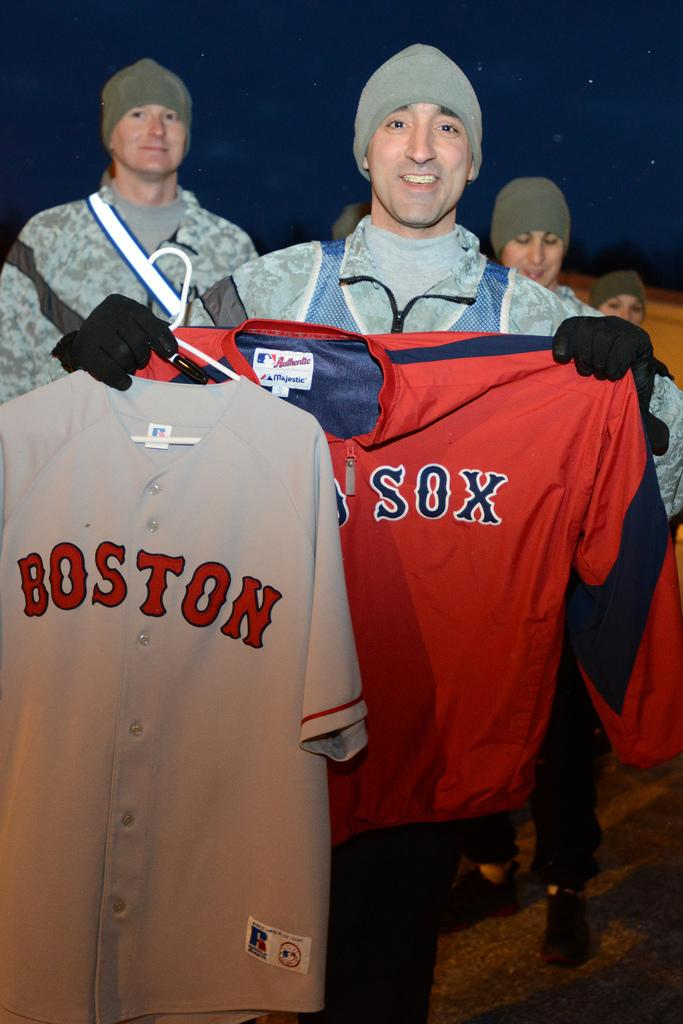What are the people in the image doing? The people in the image are standing and holding t-shirts in their hands. What else can be observed about the people in the image? The people are wearing caps. What type of sidewalk can be seen in the image? There is no sidewalk present in the image. Who is the manager in the image? There is no mention of a manager in the image. 